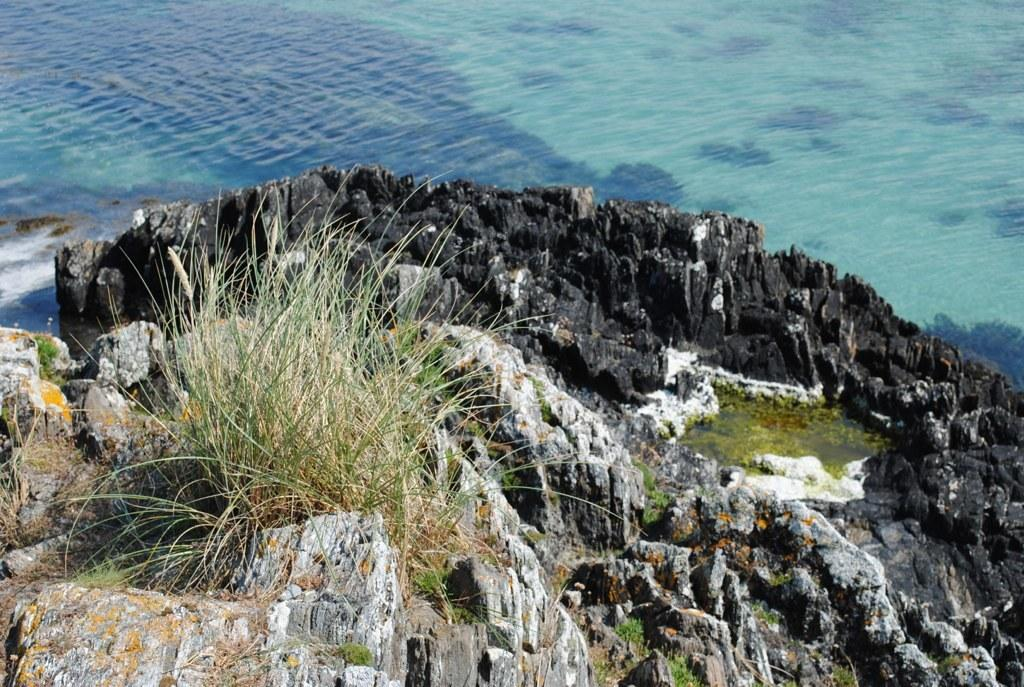What type of natural formation can be seen in the image? There are mountains in the image. What is covering the mountains in the image? The mountains are covered with grass and plants. What is present on the ground in front of the mountains? There is water present on the ground in front of the mountains. How many brothers are visible in the image? There are no brothers present in the image; it features mountains, grass, plants, and water. What type of material is the learning tool made of in the image? There is no learning tool present in the image, as it focuses on natural elements like mountains, grass, plants, and water. 